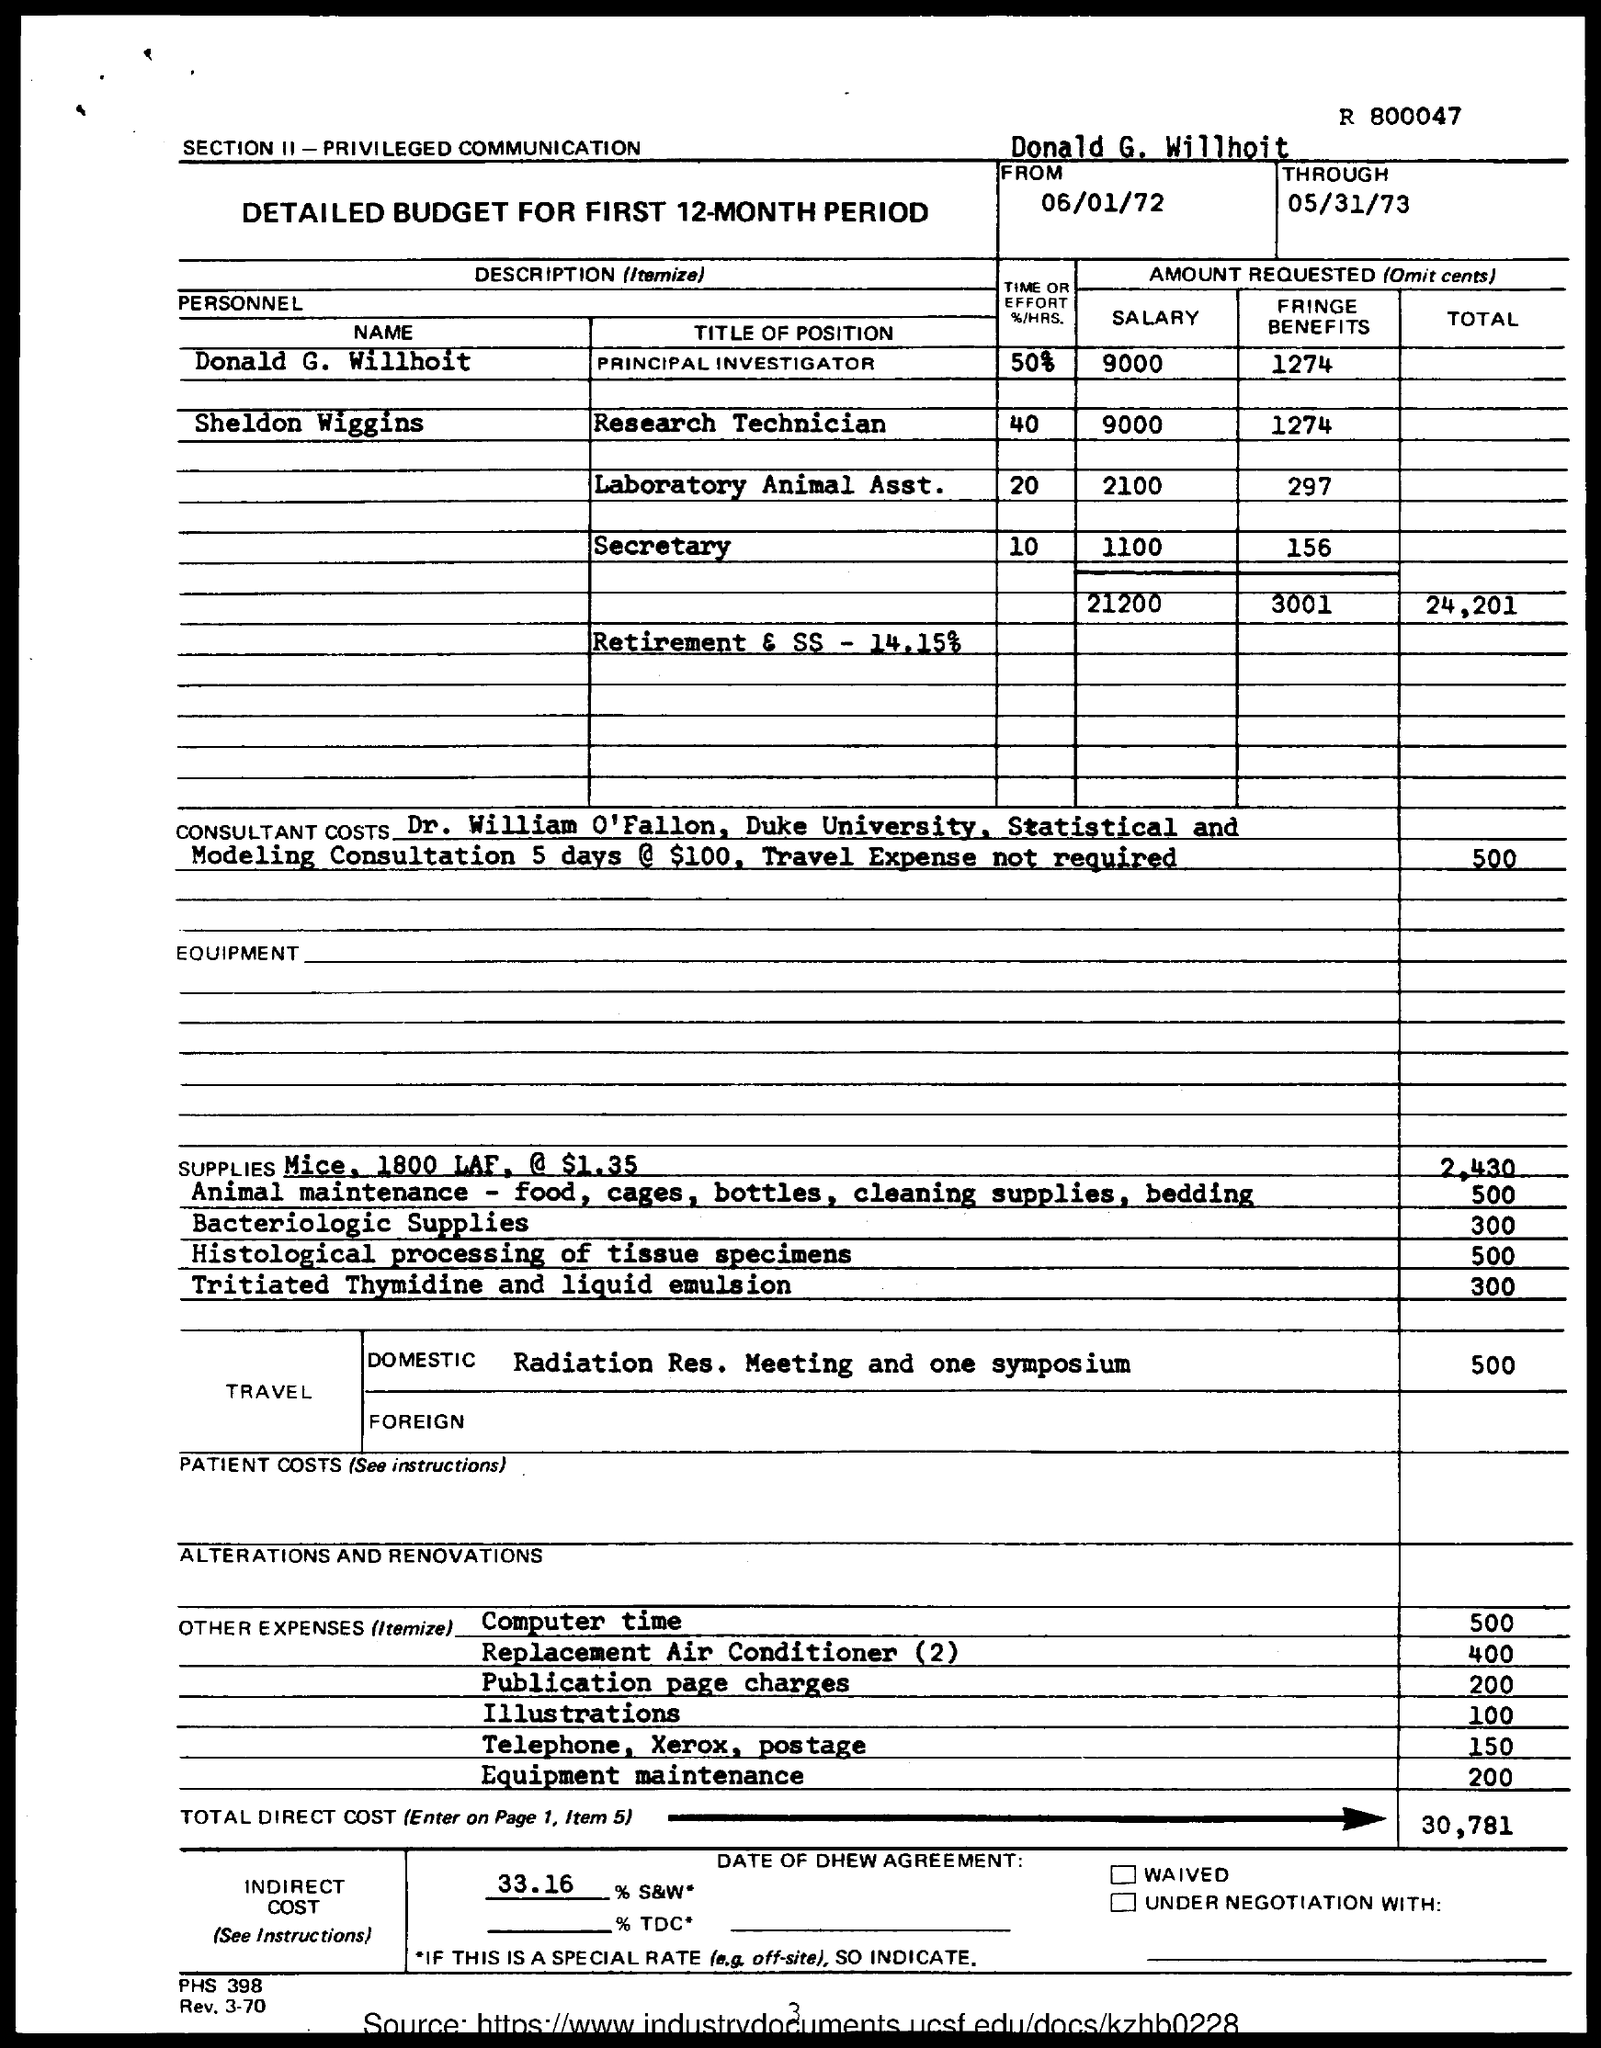What is the designation of Donald G. Willhoit?
Provide a short and direct response. Principal investigator. Second highest salary is for which position?
Offer a terse response. Laboratory Animal Asst. Who is Sheldon Wiggins?
Provide a succinct answer. Research Technician. 